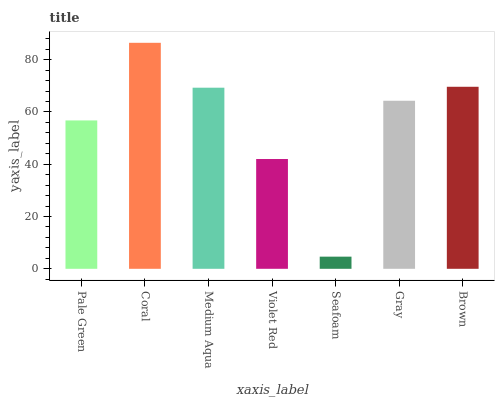Is Seafoam the minimum?
Answer yes or no. Yes. Is Coral the maximum?
Answer yes or no. Yes. Is Medium Aqua the minimum?
Answer yes or no. No. Is Medium Aqua the maximum?
Answer yes or no. No. Is Coral greater than Medium Aqua?
Answer yes or no. Yes. Is Medium Aqua less than Coral?
Answer yes or no. Yes. Is Medium Aqua greater than Coral?
Answer yes or no. No. Is Coral less than Medium Aqua?
Answer yes or no. No. Is Gray the high median?
Answer yes or no. Yes. Is Gray the low median?
Answer yes or no. Yes. Is Seafoam the high median?
Answer yes or no. No. Is Violet Red the low median?
Answer yes or no. No. 